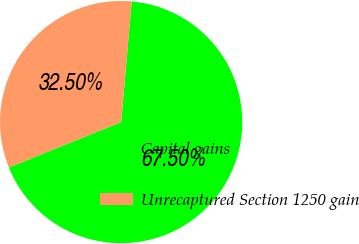Convert chart to OTSL. <chart><loc_0><loc_0><loc_500><loc_500><pie_chart><fcel>Capital gains<fcel>Unrecaptured Section 1250 gain<nl><fcel>67.5%<fcel>32.5%<nl></chart> 